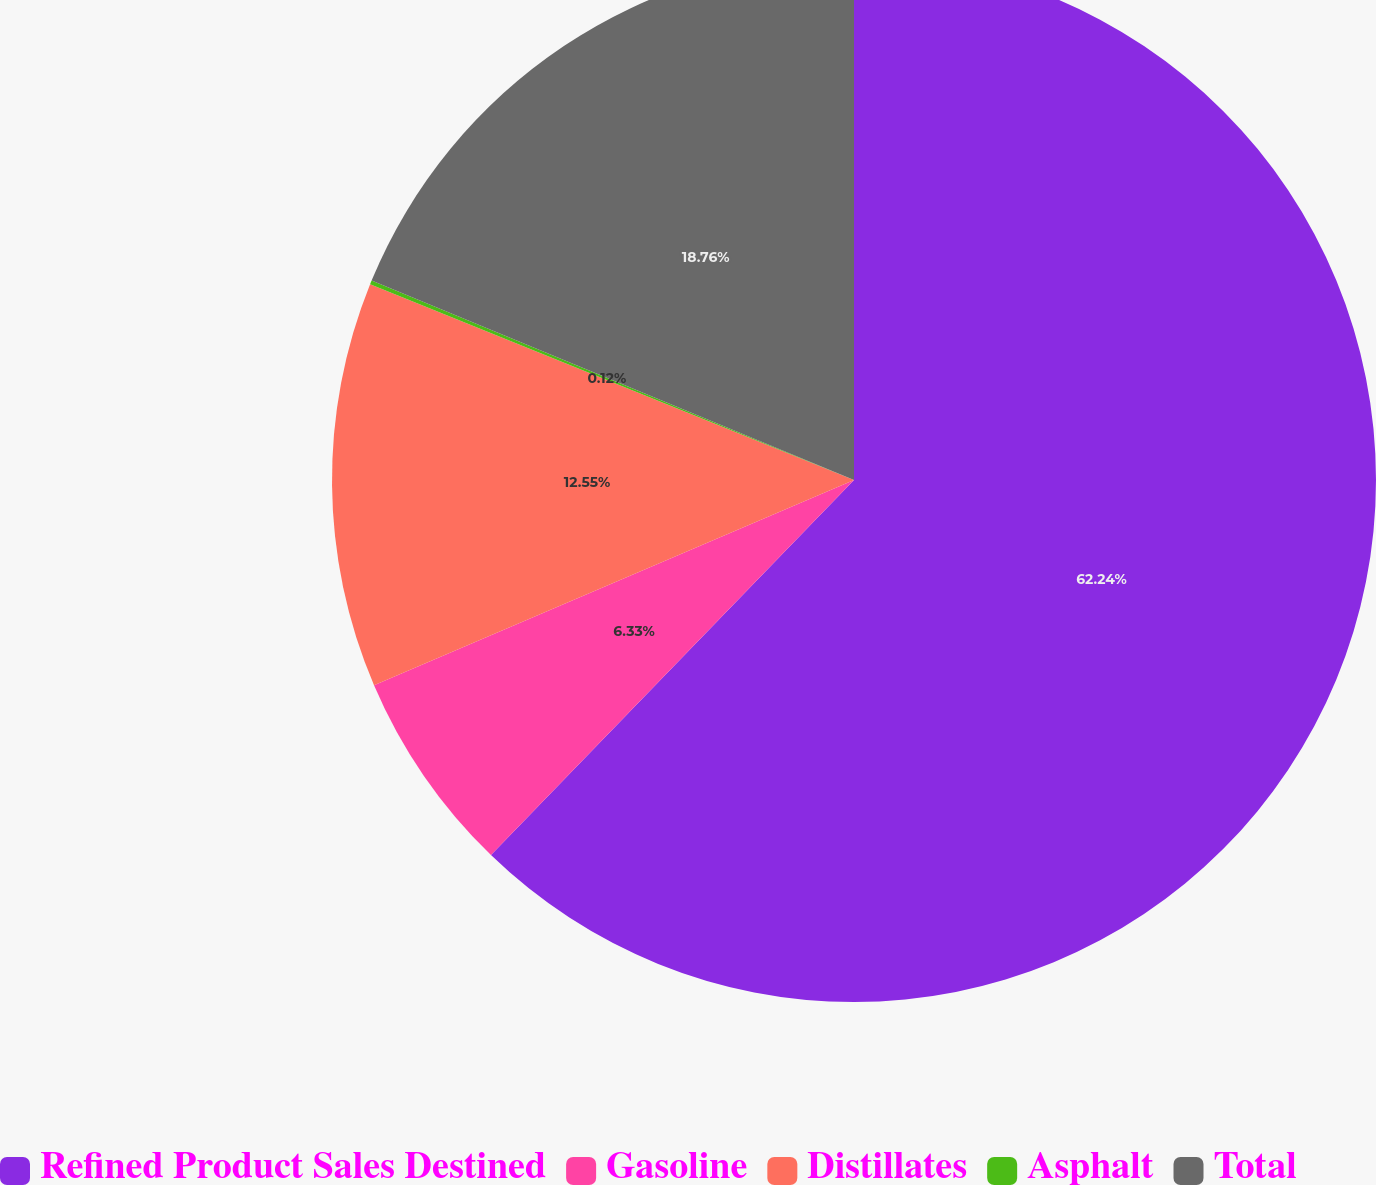Convert chart to OTSL. <chart><loc_0><loc_0><loc_500><loc_500><pie_chart><fcel>Refined Product Sales Destined<fcel>Gasoline<fcel>Distillates<fcel>Asphalt<fcel>Total<nl><fcel>62.24%<fcel>6.33%<fcel>12.55%<fcel>0.12%<fcel>18.76%<nl></chart> 